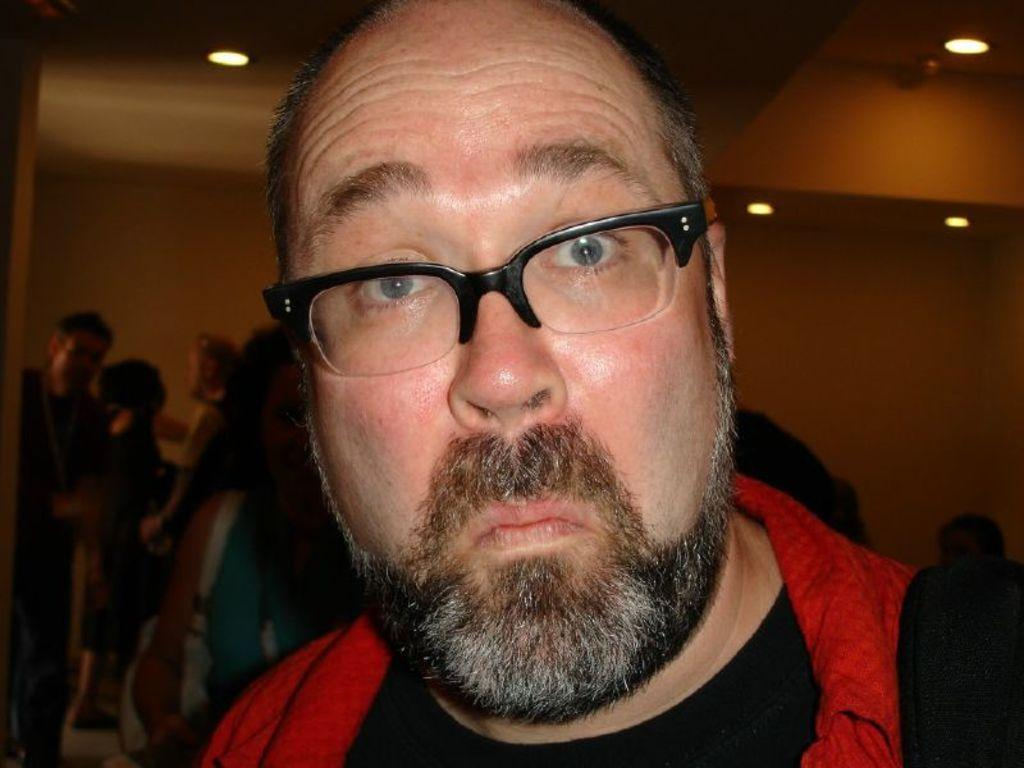What is the appearance of the man in the image? There is a man with glasses in the image. Can you describe the background of the image? There are people visible behind the man. What is above the man in the image? There is a ceiling in the image. What can be seen on the ceiling? There are ceiling lights visible on the ceiling. What type of meat is being served in the hospital cafeteria in the image? There is no hospital or cafeteria present in the image, and therefore no meat can be observed. 